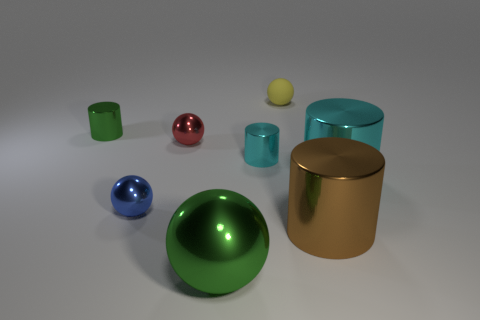There is a tiny thing that is the same color as the large shiny sphere; what shape is it?
Your response must be concise. Cylinder. There is another tiny thing that is the same shape as the small cyan object; what is its color?
Give a very brief answer. Green. There is a green object that is the same shape as the tiny yellow thing; what size is it?
Ensure brevity in your answer.  Large. The thing that is the same color as the large sphere is what size?
Your answer should be compact. Small. How many things are big brown matte blocks or tiny blue shiny objects?
Provide a short and direct response. 1. There is a big shiny thing to the left of the small matte object; is its color the same as the tiny shiny cylinder to the right of the big green thing?
Give a very brief answer. No. The yellow object that is the same size as the red sphere is what shape?
Provide a succinct answer. Sphere. What number of objects are green metal spheres that are in front of the red object or shiny cylinders left of the green ball?
Provide a short and direct response. 2. Are there fewer small cyan metal cylinders than large brown metallic cubes?
Ensure brevity in your answer.  No. There is a yellow sphere that is the same size as the blue object; what material is it?
Make the answer very short. Rubber. 